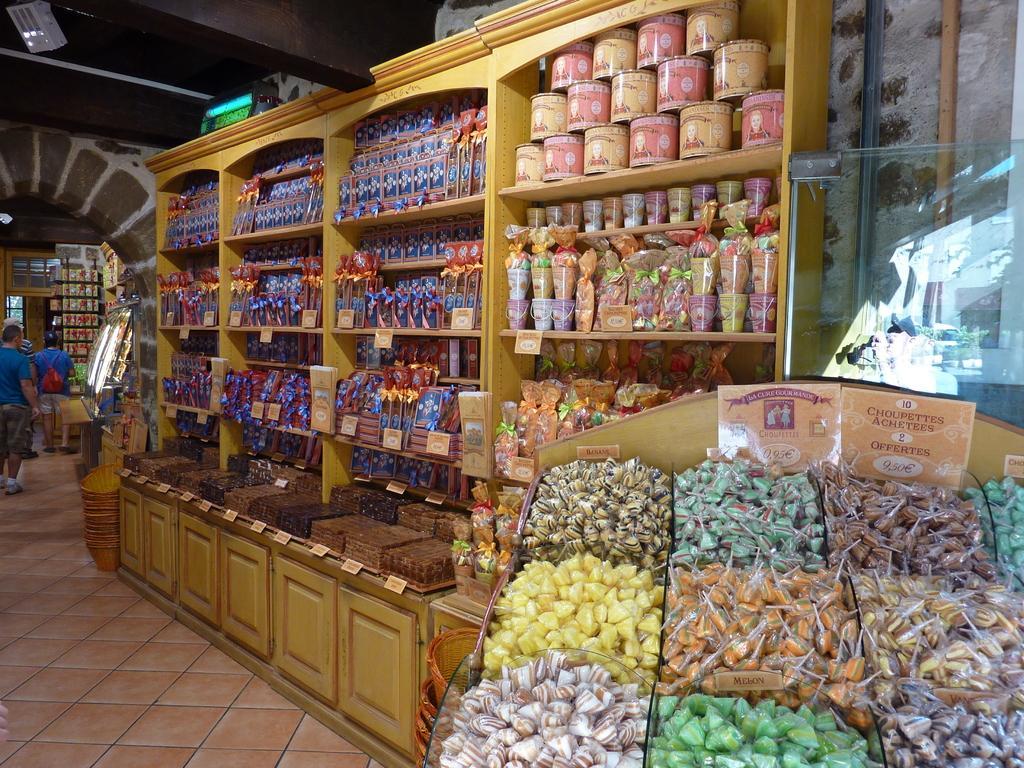How would you summarize this image in a sentence or two? In this image we can see object arranged in a shelf. There are people standing. At the bottom of the image there is floor. At the top of the image there is ceiling. 